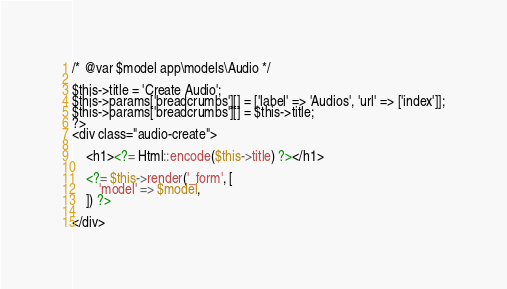<code> <loc_0><loc_0><loc_500><loc_500><_PHP_>/* @var $model app\models\Audio */

$this->title = 'Create Audio';
$this->params['breadcrumbs'][] = ['label' => 'Audios', 'url' => ['index']];
$this->params['breadcrumbs'][] = $this->title;
?>
<div class="audio-create">

    <h1><?= Html::encode($this->title) ?></h1>

    <?= $this->render('_form', [
        'model' => $model,
    ]) ?>

</div>
</code> 